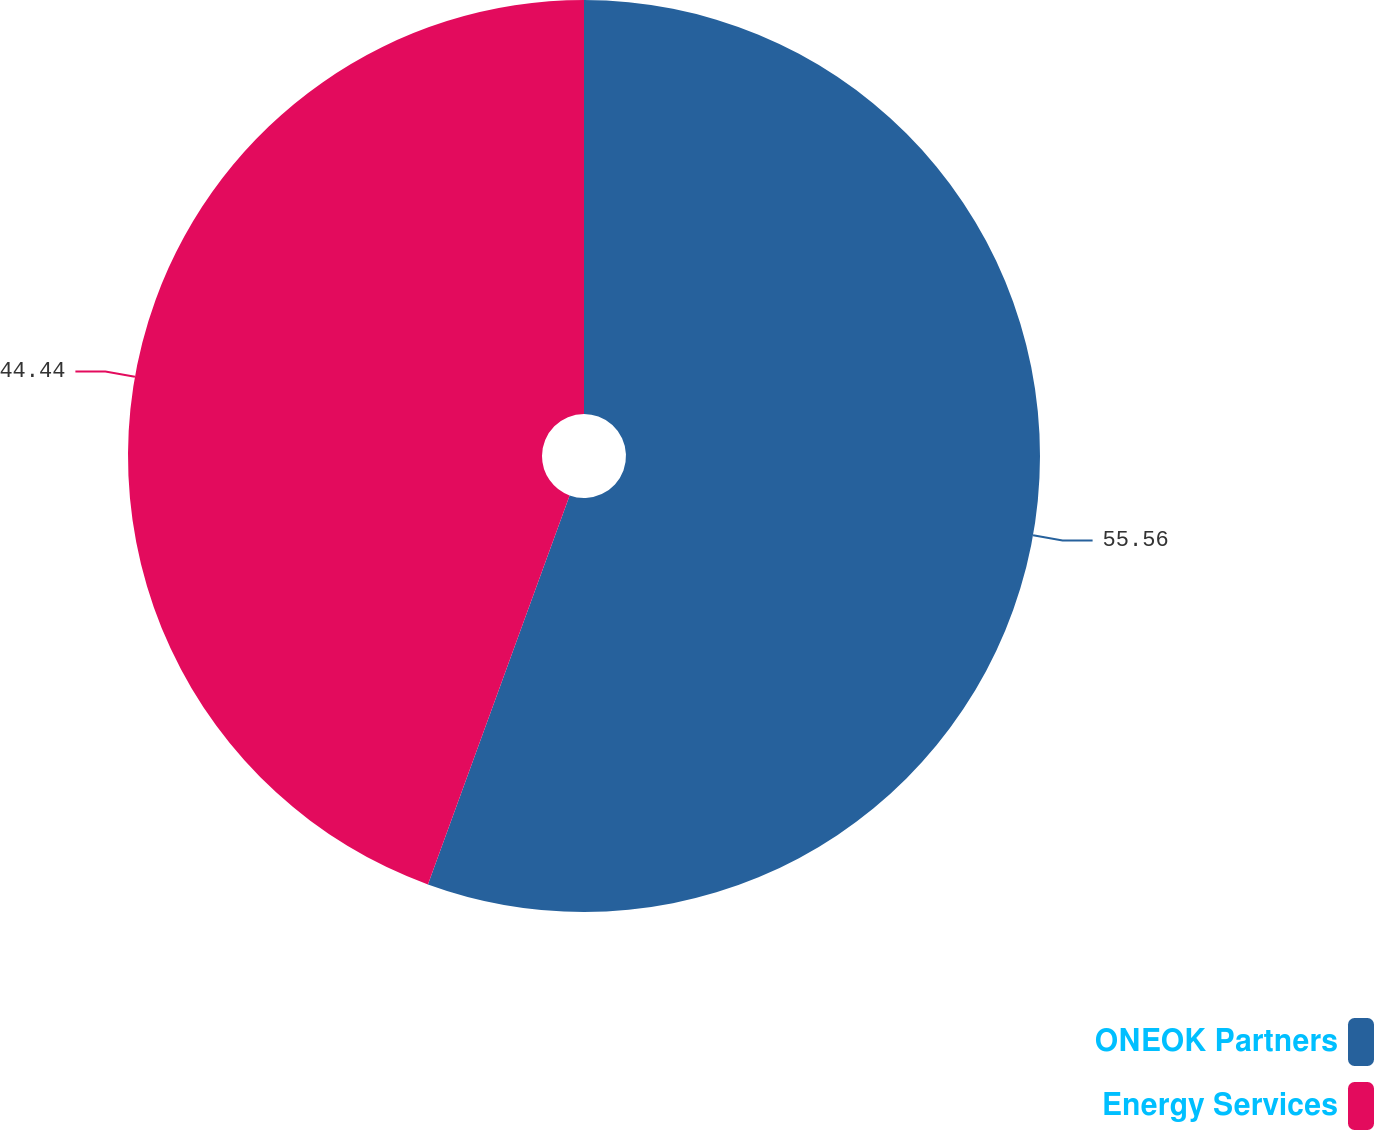Convert chart to OTSL. <chart><loc_0><loc_0><loc_500><loc_500><pie_chart><fcel>ONEOK Partners<fcel>Energy Services<nl><fcel>55.56%<fcel>44.44%<nl></chart> 